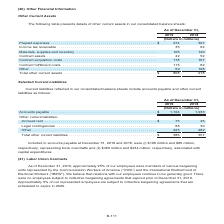According to Centurylink's financial document, What do the current liabilities reflected in the consolidated balance sheets include? accounts payable and other current liabilities. The document states: "lected in our consolidated balance sheets include accounts payable and other current liabilities as follows:..." Also, What are the items included in accounts payable? The document shows two values: book overdrafts and capital expenditures. From the document: "n and $434 million, respectively, associated with capital expenditures. llion and $86 million, respectively, representing book overdrafts and (ii) $46..." Also, What are the items included under Other current liabilities? The document contains multiple relevant values: Accrued rent, Legal contingencies, Other. From the document: "Other current liabilities: Accrued rent . $ 75 45 Legal contingencies . 88 30 Other . 223 282 Other current liabilities: Accrued rent . $ 75 45 Legal ..." Additionally, Which year has a larger amount of accounts payable associated with capital expenditures? According to the financial document, 2019. The relevant text states: "As of December 31, 2019 2018..." Also, can you calculate: What is the change in accrued rent in 2019? Based on the calculation: 75-45, the result is 30 (in millions). This is based on the information: "Other current liabilities: Accrued rent . $ 75 45 Legal contingencies . 88 30 Other . 223 282 Other current liabilities: Accrued rent . $ 75 45 Legal contingencies . 88 30 Other . 223 282..." The key data points involved are: 45, 75. Also, can you calculate: What is the percentage change in legal contingencies in 2019? To answer this question, I need to perform calculations using the financial data. The calculation is: (88-30)/30, which equals 193.33 (percentage). This is based on the information: ": Accrued rent . $ 75 45 Legal contingencies . 88 30 Other . 223 282 ies: Accrued rent . $ 75 45 Legal contingencies . 88 30 Other . 223 282..." The key data points involved are: 30, 88. 